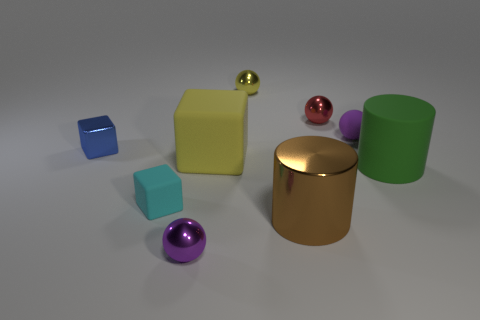What number of big shiny things are in front of the purple object that is behind the green matte cylinder?
Provide a short and direct response. 1. Are there fewer blue objects to the right of the brown metal object than small metal things?
Provide a succinct answer. Yes. There is a small purple object that is left of the large yellow cube behind the big matte cylinder; is there a small yellow object left of it?
Keep it short and to the point. No. Do the yellow block and the tiny purple sphere in front of the small blue metal block have the same material?
Your answer should be compact. No. There is a matte thing that is on the left side of the sphere in front of the tiny rubber sphere; what color is it?
Your answer should be compact. Cyan. Is there a small thing that has the same color as the metallic cylinder?
Offer a very short reply. No. How big is the yellow rubber block in front of the blue shiny cube behind the small metal sphere in front of the tiny red sphere?
Provide a succinct answer. Large. There is a tiny yellow object; does it have the same shape as the purple object that is behind the green cylinder?
Ensure brevity in your answer.  Yes. What number of other objects are the same size as the brown cylinder?
Your answer should be very brief. 2. How big is the metal ball to the left of the small yellow object?
Keep it short and to the point. Small. 